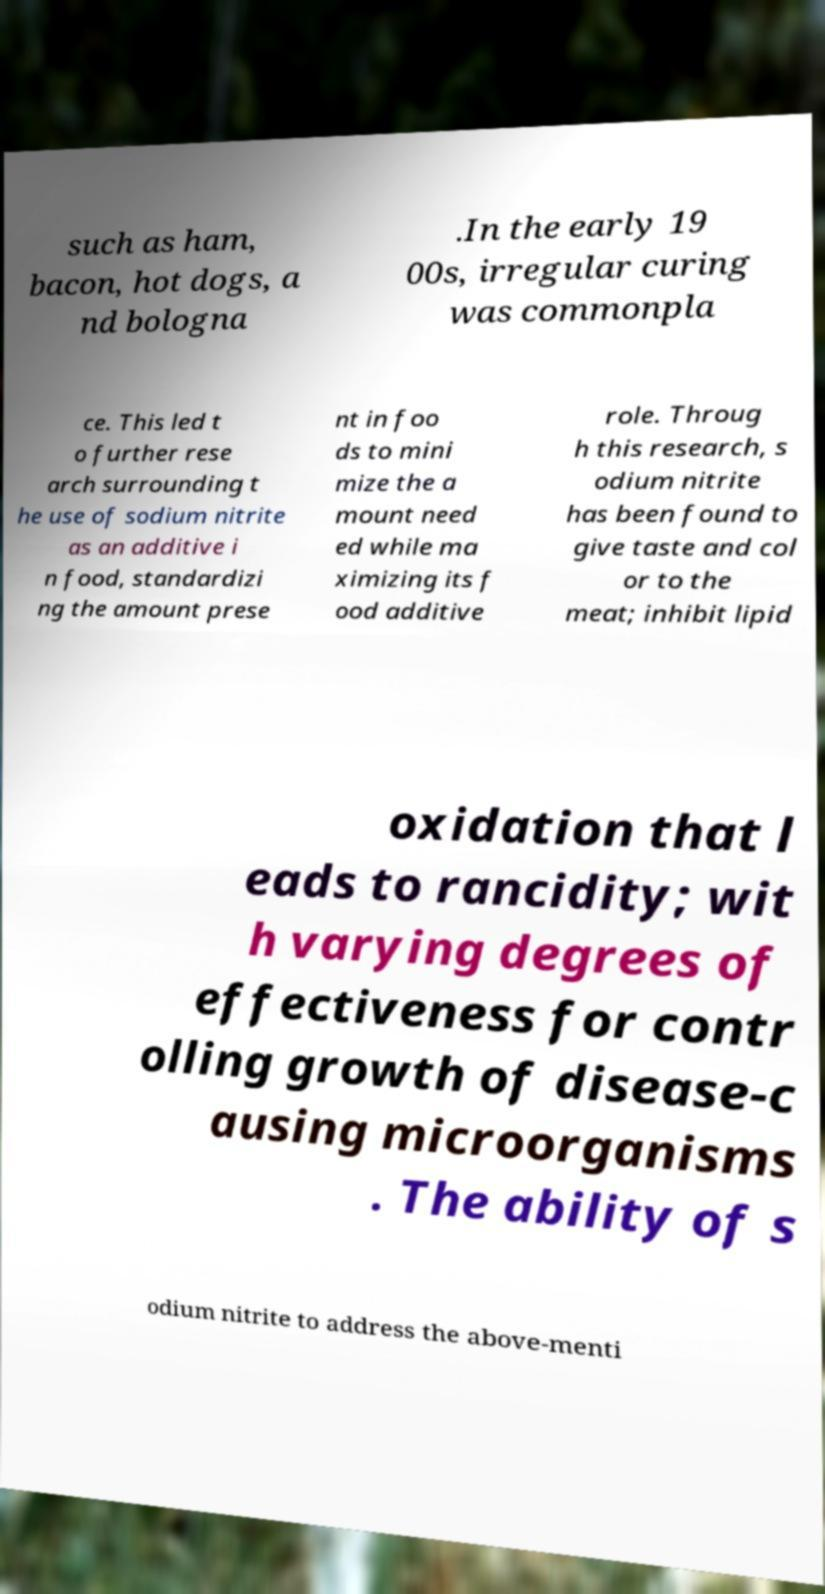Could you assist in decoding the text presented in this image and type it out clearly? such as ham, bacon, hot dogs, a nd bologna .In the early 19 00s, irregular curing was commonpla ce. This led t o further rese arch surrounding t he use of sodium nitrite as an additive i n food, standardizi ng the amount prese nt in foo ds to mini mize the a mount need ed while ma ximizing its f ood additive role. Throug h this research, s odium nitrite has been found to give taste and col or to the meat; inhibit lipid oxidation that l eads to rancidity; wit h varying degrees of effectiveness for contr olling growth of disease-c ausing microorganisms . The ability of s odium nitrite to address the above-menti 